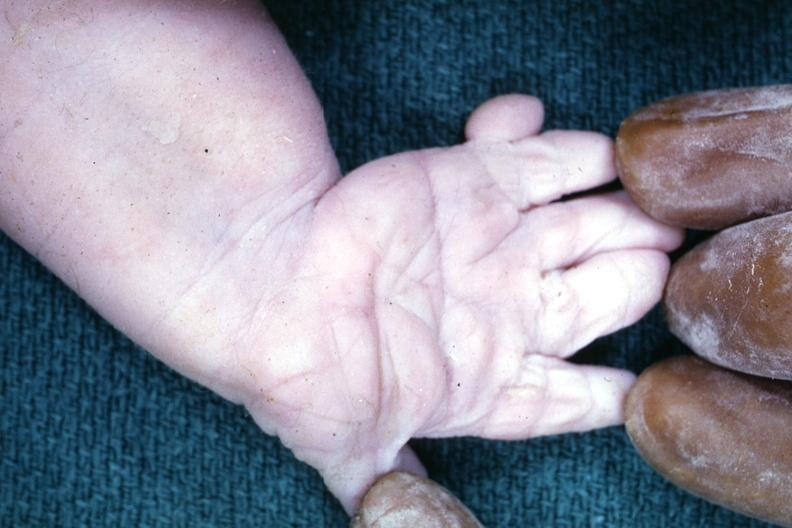what is present?
Answer the question using a single word or phrase. Hand 